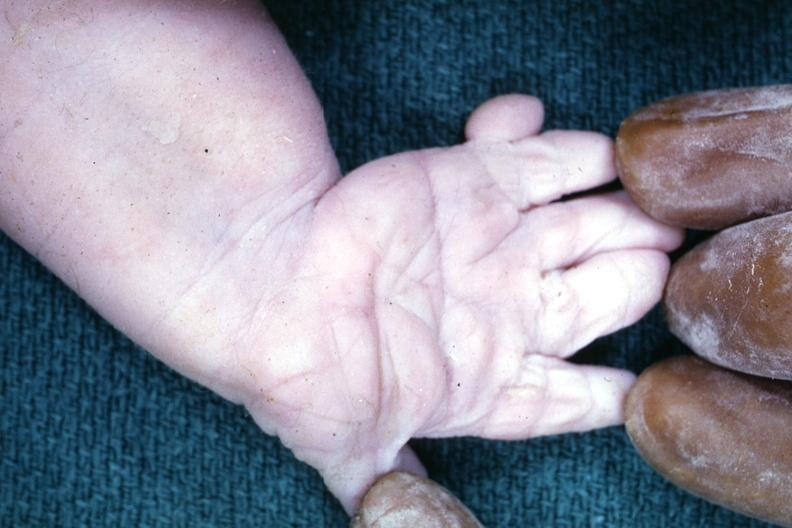what is present?
Answer the question using a single word or phrase. Hand 